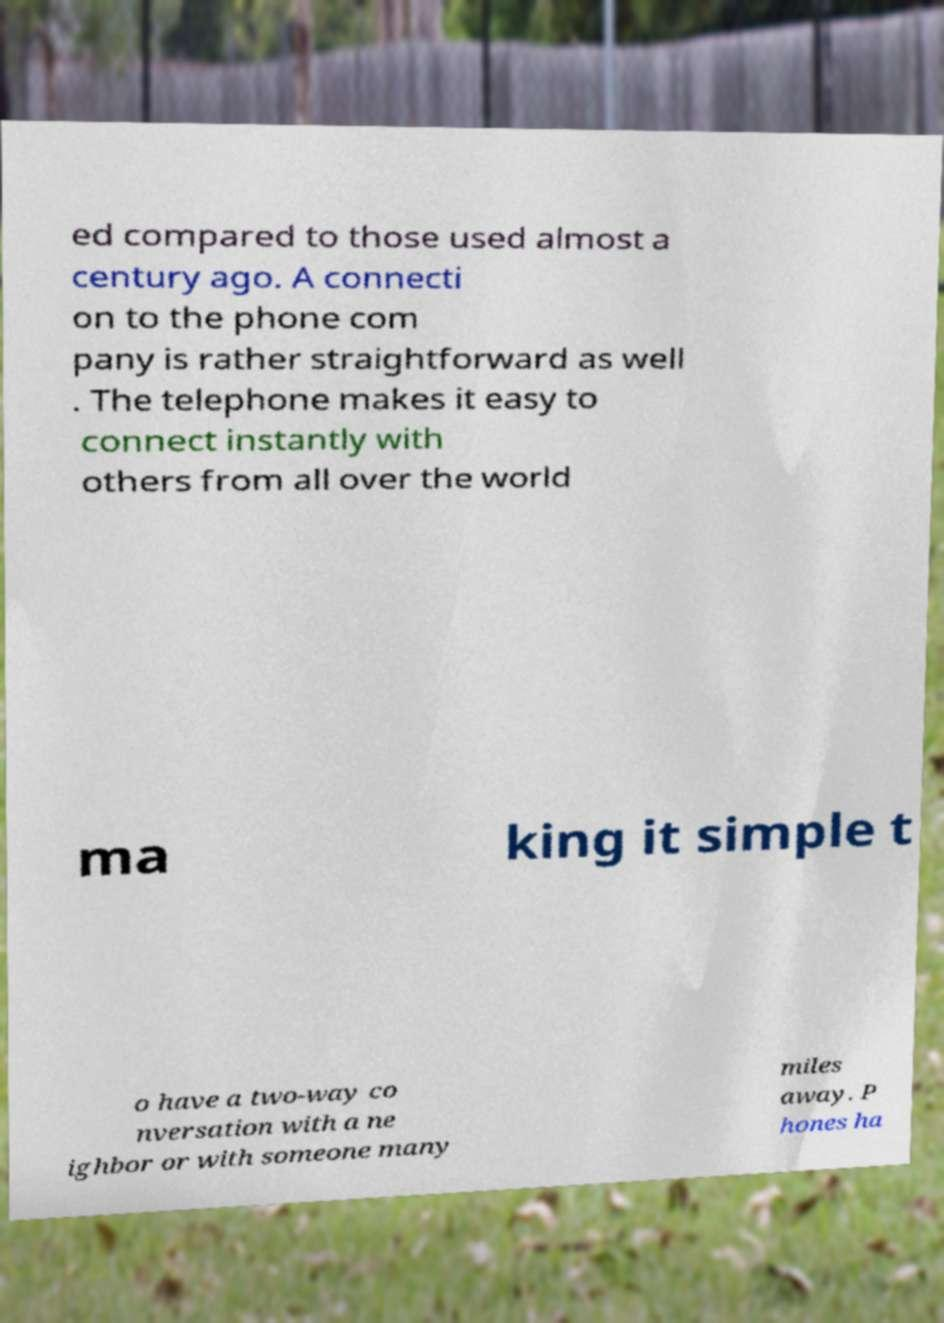There's text embedded in this image that I need extracted. Can you transcribe it verbatim? ed compared to those used almost a century ago. A connecti on to the phone com pany is rather straightforward as well . The telephone makes it easy to connect instantly with others from all over the world ma king it simple t o have a two-way co nversation with a ne ighbor or with someone many miles away. P hones ha 